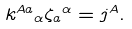<formula> <loc_0><loc_0><loc_500><loc_500>k ^ { A a } { _ { \alpha } } \zeta _ { a } { ^ { \alpha } } = j ^ { A } .</formula> 